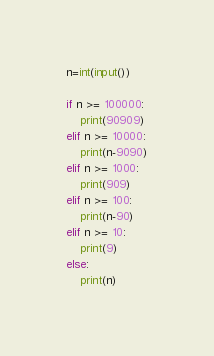Convert code to text. <code><loc_0><loc_0><loc_500><loc_500><_Python_>n=int(input())

if n >= 100000:
    print(90909)
elif n >= 10000:
    print(n-9090)
elif n >= 1000:
    print(909)
elif n >= 100:
    print(n-90)
elif n >= 10:
    print(9)
else:
    print(n)

</code> 